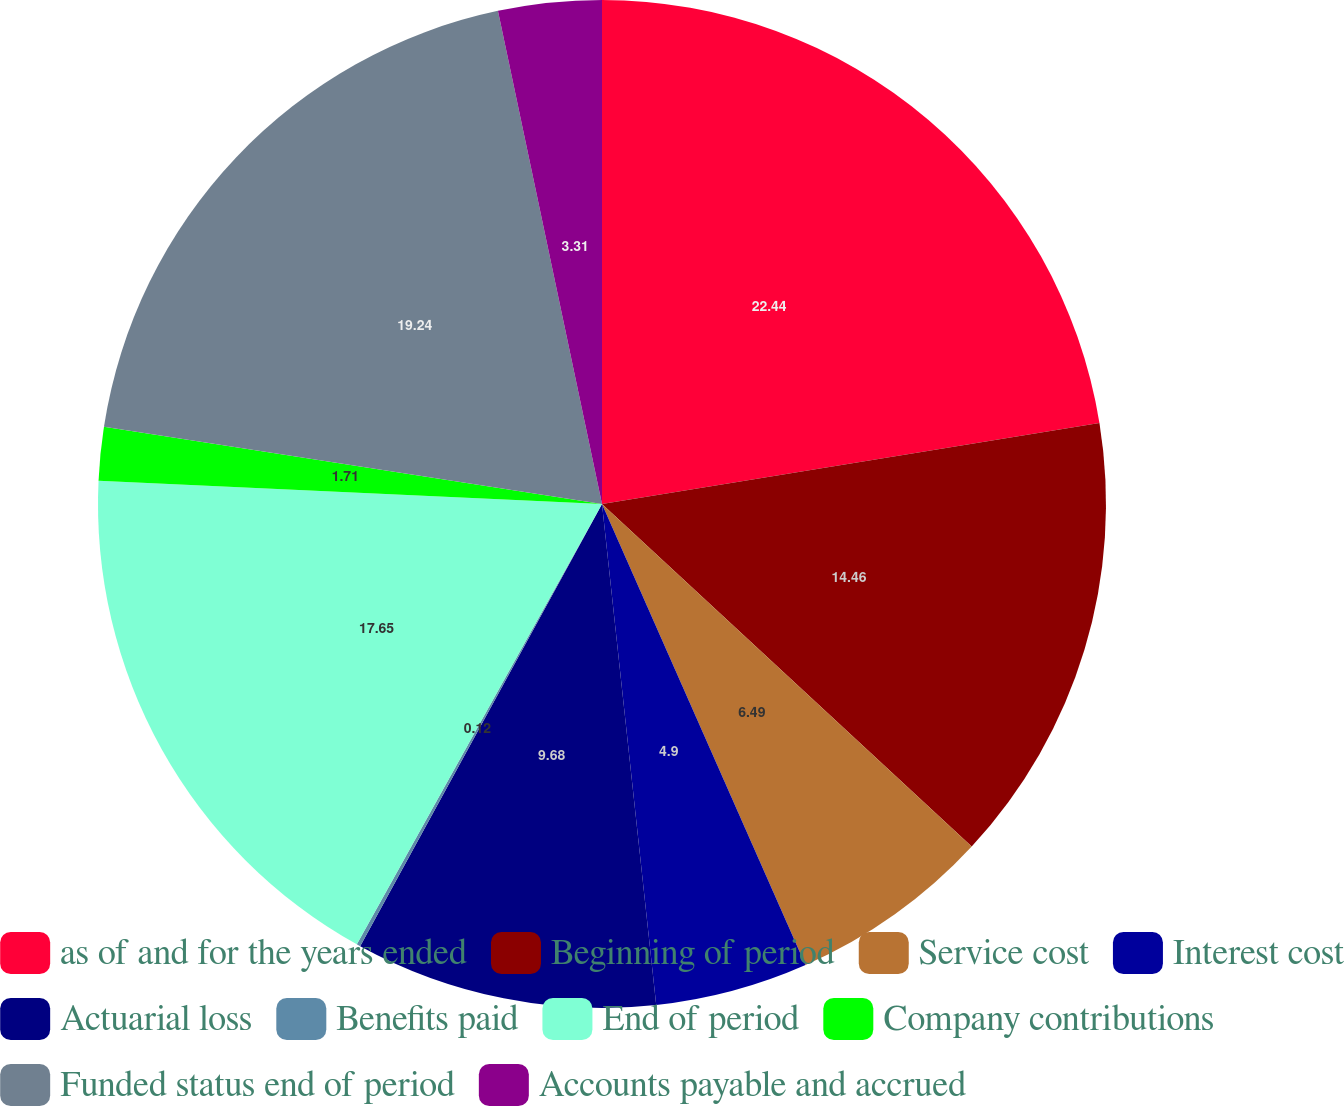<chart> <loc_0><loc_0><loc_500><loc_500><pie_chart><fcel>as of and for the years ended<fcel>Beginning of period<fcel>Service cost<fcel>Interest cost<fcel>Actuarial loss<fcel>Benefits paid<fcel>End of period<fcel>Company contributions<fcel>Funded status end of period<fcel>Accounts payable and accrued<nl><fcel>22.43%<fcel>14.46%<fcel>6.49%<fcel>4.9%<fcel>9.68%<fcel>0.12%<fcel>17.65%<fcel>1.71%<fcel>19.24%<fcel>3.31%<nl></chart> 